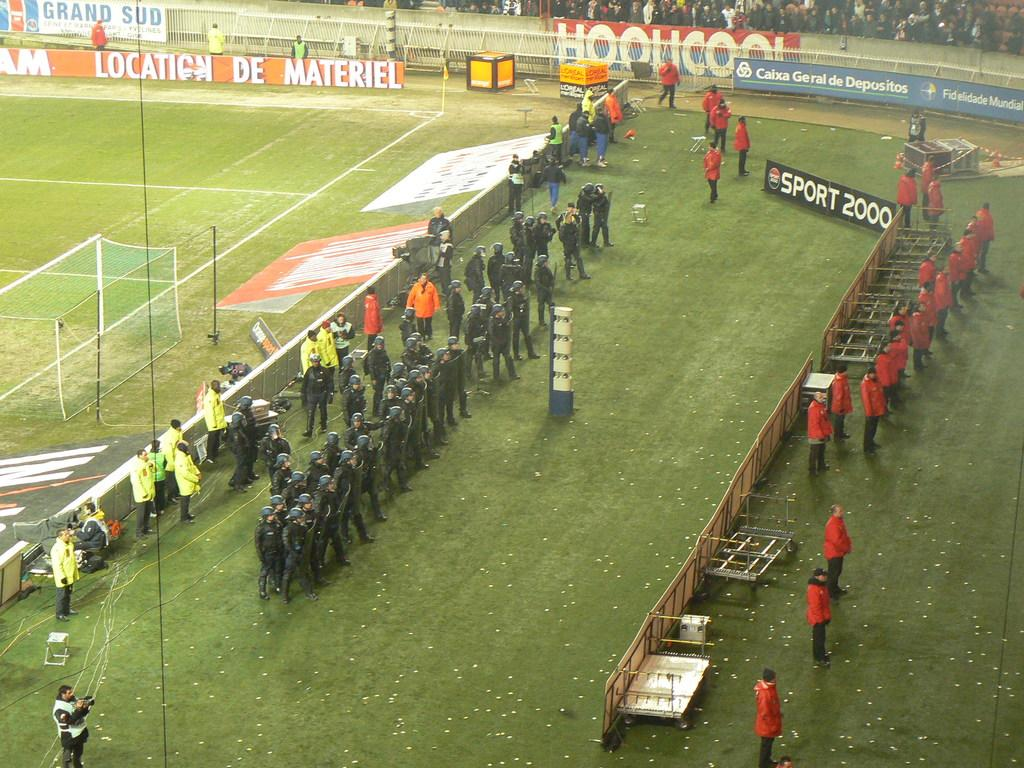What is the main setting of the image? There are people in a stadium, which is the main setting. What type of surface is visible in the image? There is a football court visible in the image. What can be seen on the ground with grass? There are people on the ground with grass. What additional objects or features are present in the image? There are posters and poles in the image. Can you tell me how many soldiers are present in the image? There is no army or soldiers present in the image; it features a stadium with people and a football court. What type of smile can be seen on the poster in the image? There is no smile or poster with a smile present in the image; it only features posters and poles as additional objects or features. 